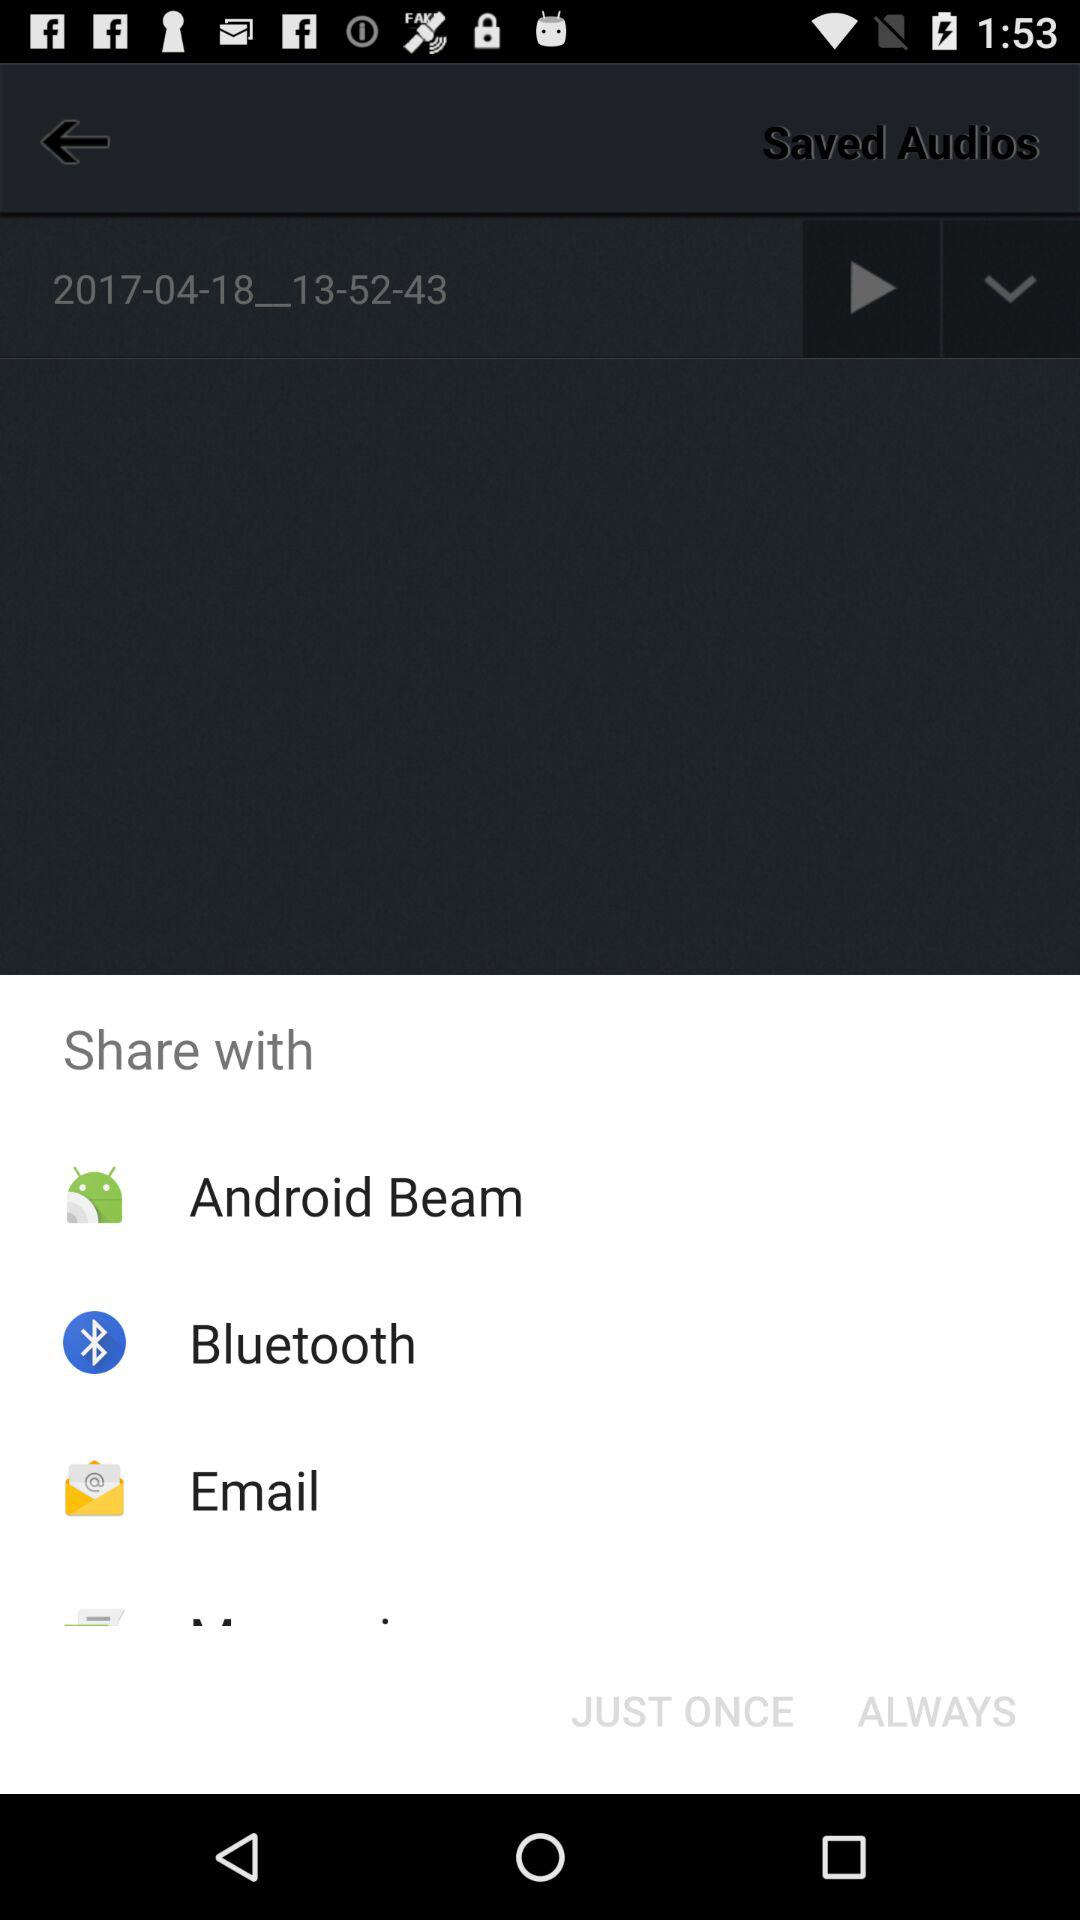What are the alternatives for sharing? The alternatives for sharing are "Android Beam", "Bluetooth", and "Email". 